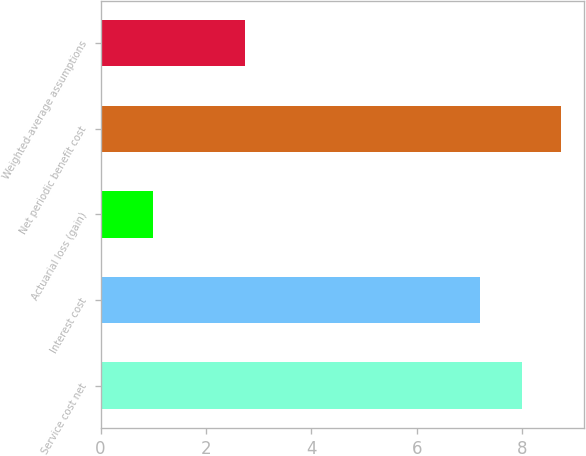Convert chart to OTSL. <chart><loc_0><loc_0><loc_500><loc_500><bar_chart><fcel>Service cost net<fcel>Interest cost<fcel>Actuarial loss (gain)<fcel>Net periodic benefit cost<fcel>Weighted-average assumptions<nl><fcel>8<fcel>7.2<fcel>1<fcel>8.73<fcel>2.75<nl></chart> 